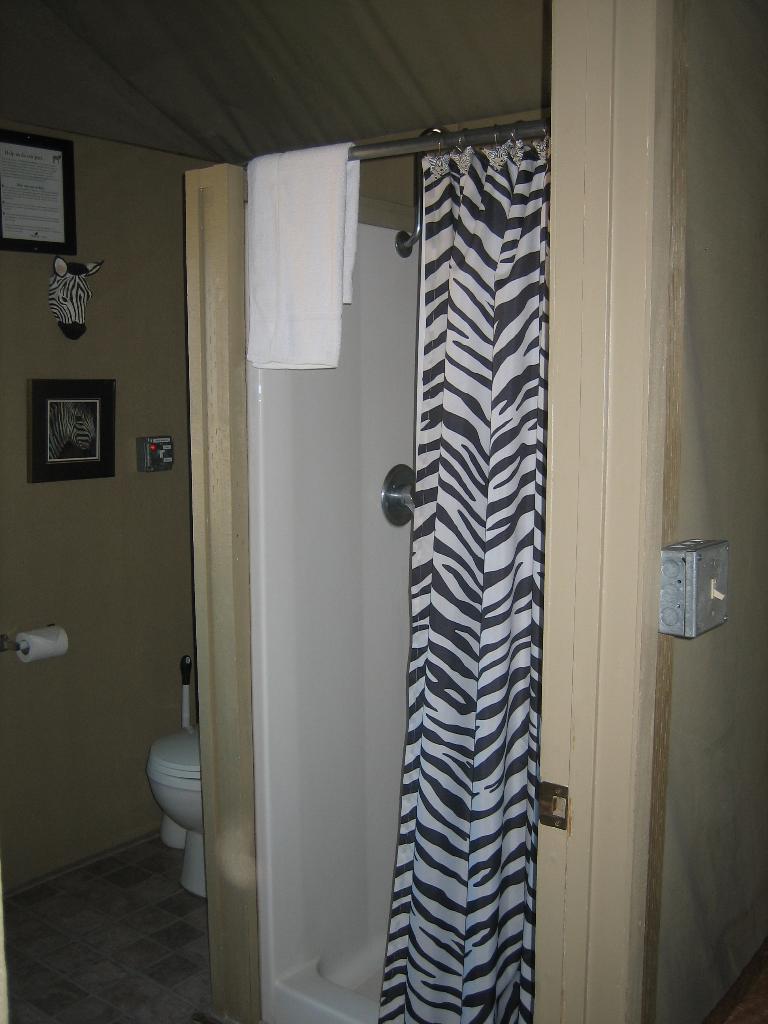Please provide a concise description of this image. In the image it looks like a washroom there is a towel, curtain, toilet seat, toilet paper, photo frames and few other objects in the image. 